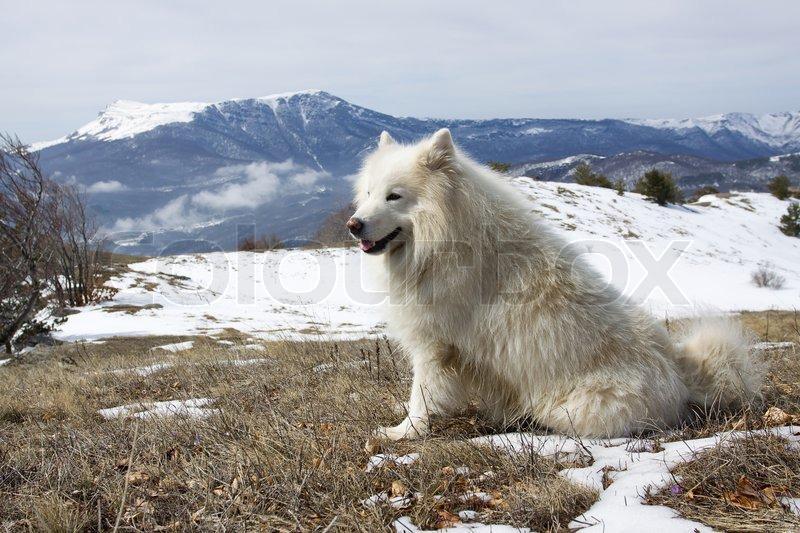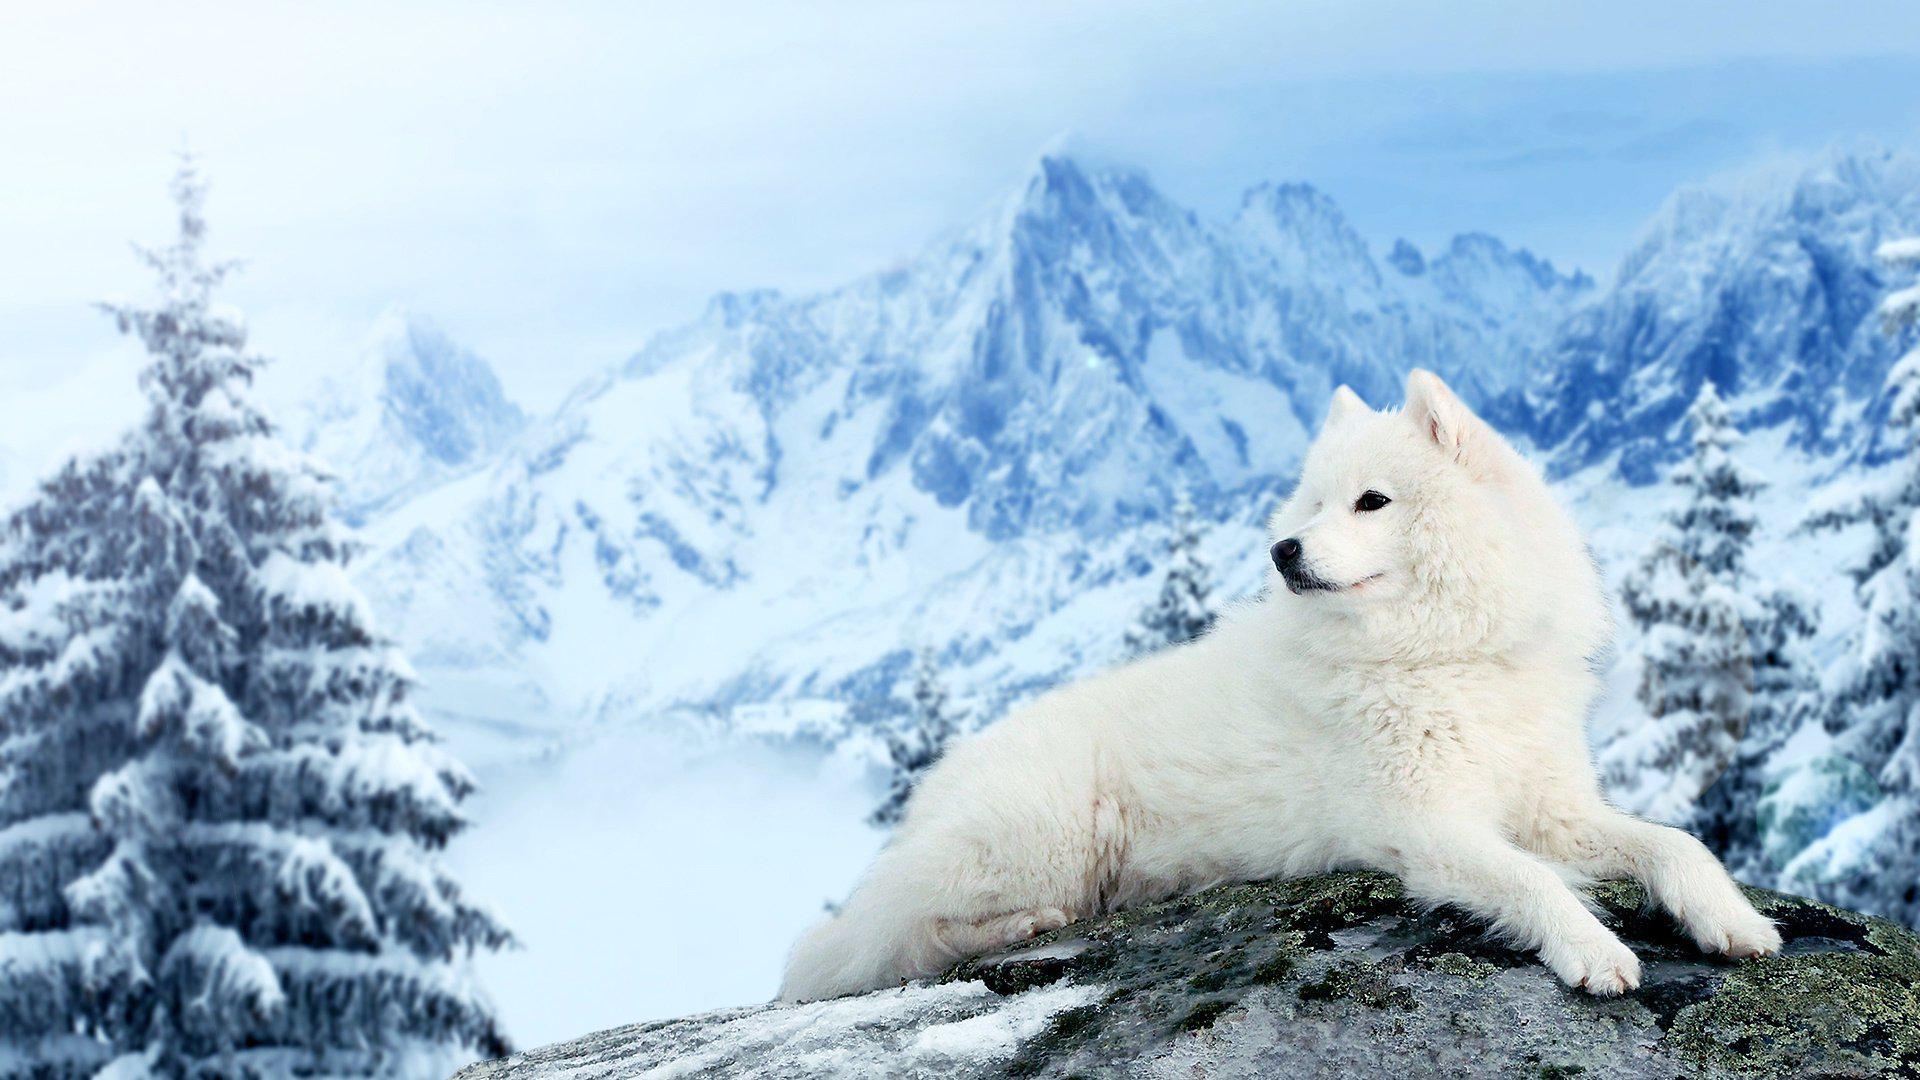The first image is the image on the left, the second image is the image on the right. Analyze the images presented: Is the assertion "Two white dogs wearing matching packs are side-by-side on an overlook, with hilly scenery in the background." valid? Answer yes or no. No. The first image is the image on the left, the second image is the image on the right. Assess this claim about the two images: "There are three dogs in the image pair.". Correct or not? Answer yes or no. No. 